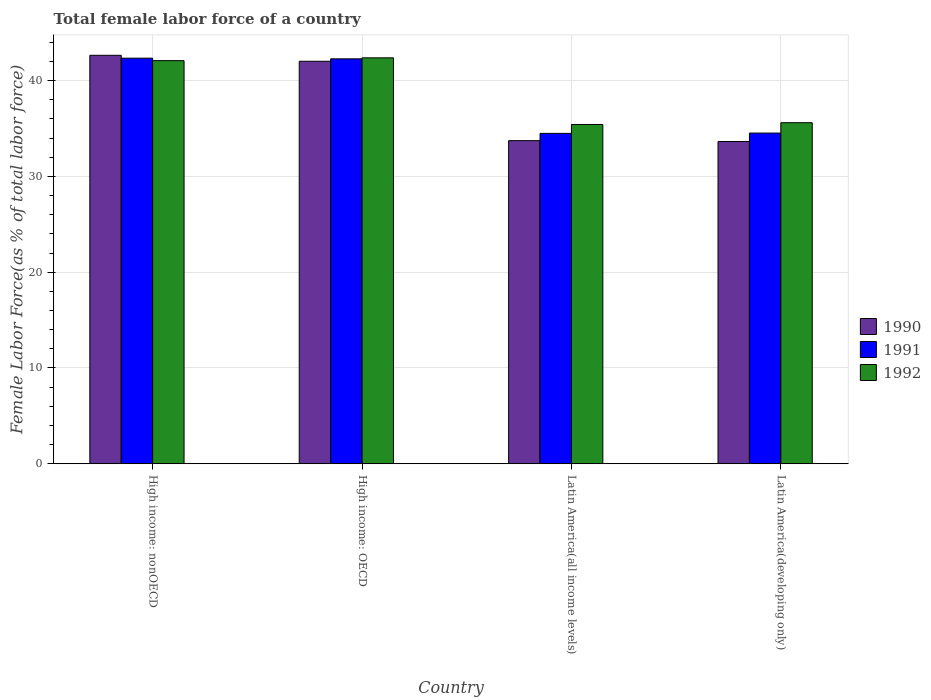Are the number of bars per tick equal to the number of legend labels?
Offer a very short reply. Yes. Are the number of bars on each tick of the X-axis equal?
Keep it short and to the point. Yes. How many bars are there on the 4th tick from the left?
Offer a terse response. 3. What is the label of the 1st group of bars from the left?
Provide a succinct answer. High income: nonOECD. What is the percentage of female labor force in 1992 in High income: nonOECD?
Offer a terse response. 42.08. Across all countries, what is the maximum percentage of female labor force in 1990?
Offer a very short reply. 42.64. Across all countries, what is the minimum percentage of female labor force in 1990?
Your answer should be compact. 33.64. In which country was the percentage of female labor force in 1992 maximum?
Offer a very short reply. High income: OECD. In which country was the percentage of female labor force in 1992 minimum?
Offer a terse response. Latin America(all income levels). What is the total percentage of female labor force in 1990 in the graph?
Your answer should be very brief. 152.04. What is the difference between the percentage of female labor force in 1990 in High income: OECD and that in High income: nonOECD?
Provide a succinct answer. -0.62. What is the difference between the percentage of female labor force in 1990 in Latin America(all income levels) and the percentage of female labor force in 1992 in Latin America(developing only)?
Provide a short and direct response. -1.87. What is the average percentage of female labor force in 1991 per country?
Provide a short and direct response. 38.41. What is the difference between the percentage of female labor force of/in 1990 and percentage of female labor force of/in 1991 in High income: nonOECD?
Ensure brevity in your answer.  0.3. What is the ratio of the percentage of female labor force in 1992 in High income: OECD to that in Latin America(all income levels)?
Ensure brevity in your answer.  1.2. Is the percentage of female labor force in 1991 in High income: OECD less than that in Latin America(developing only)?
Your answer should be compact. No. What is the difference between the highest and the second highest percentage of female labor force in 1992?
Your response must be concise. 6.77. What is the difference between the highest and the lowest percentage of female labor force in 1991?
Your response must be concise. 7.85. Is the sum of the percentage of female labor force in 1992 in High income: OECD and High income: nonOECD greater than the maximum percentage of female labor force in 1990 across all countries?
Ensure brevity in your answer.  Yes. What does the 2nd bar from the left in Latin America(all income levels) represents?
Your answer should be compact. 1991. Is it the case that in every country, the sum of the percentage of female labor force in 1992 and percentage of female labor force in 1991 is greater than the percentage of female labor force in 1990?
Give a very brief answer. Yes. How many bars are there?
Provide a succinct answer. 12. Are all the bars in the graph horizontal?
Provide a short and direct response. No. What is the difference between two consecutive major ticks on the Y-axis?
Your answer should be compact. 10. What is the title of the graph?
Provide a succinct answer. Total female labor force of a country. What is the label or title of the Y-axis?
Give a very brief answer. Female Labor Force(as % of total labor force). What is the Female Labor Force(as % of total labor force) in 1990 in High income: nonOECD?
Keep it short and to the point. 42.64. What is the Female Labor Force(as % of total labor force) in 1991 in High income: nonOECD?
Your answer should be very brief. 42.34. What is the Female Labor Force(as % of total labor force) in 1992 in High income: nonOECD?
Make the answer very short. 42.08. What is the Female Labor Force(as % of total labor force) in 1990 in High income: OECD?
Offer a terse response. 42.02. What is the Female Labor Force(as % of total labor force) of 1991 in High income: OECD?
Make the answer very short. 42.27. What is the Female Labor Force(as % of total labor force) of 1992 in High income: OECD?
Give a very brief answer. 42.38. What is the Female Labor Force(as % of total labor force) of 1990 in Latin America(all income levels)?
Your answer should be compact. 33.73. What is the Female Labor Force(as % of total labor force) of 1991 in Latin America(all income levels)?
Keep it short and to the point. 34.49. What is the Female Labor Force(as % of total labor force) in 1992 in Latin America(all income levels)?
Give a very brief answer. 35.42. What is the Female Labor Force(as % of total labor force) of 1990 in Latin America(developing only)?
Provide a short and direct response. 33.64. What is the Female Labor Force(as % of total labor force) of 1991 in Latin America(developing only)?
Keep it short and to the point. 34.52. What is the Female Labor Force(as % of total labor force) of 1992 in Latin America(developing only)?
Provide a succinct answer. 35.6. Across all countries, what is the maximum Female Labor Force(as % of total labor force) of 1990?
Offer a terse response. 42.64. Across all countries, what is the maximum Female Labor Force(as % of total labor force) of 1991?
Your answer should be compact. 42.34. Across all countries, what is the maximum Female Labor Force(as % of total labor force) in 1992?
Ensure brevity in your answer.  42.38. Across all countries, what is the minimum Female Labor Force(as % of total labor force) of 1990?
Make the answer very short. 33.64. Across all countries, what is the minimum Female Labor Force(as % of total labor force) in 1991?
Give a very brief answer. 34.49. Across all countries, what is the minimum Female Labor Force(as % of total labor force) of 1992?
Make the answer very short. 35.42. What is the total Female Labor Force(as % of total labor force) of 1990 in the graph?
Make the answer very short. 152.04. What is the total Female Labor Force(as % of total labor force) in 1991 in the graph?
Your answer should be very brief. 153.63. What is the total Female Labor Force(as % of total labor force) of 1992 in the graph?
Offer a very short reply. 155.49. What is the difference between the Female Labor Force(as % of total labor force) in 1990 in High income: nonOECD and that in High income: OECD?
Offer a terse response. 0.62. What is the difference between the Female Labor Force(as % of total labor force) in 1991 in High income: nonOECD and that in High income: OECD?
Keep it short and to the point. 0.07. What is the difference between the Female Labor Force(as % of total labor force) of 1992 in High income: nonOECD and that in High income: OECD?
Your answer should be compact. -0.29. What is the difference between the Female Labor Force(as % of total labor force) of 1990 in High income: nonOECD and that in Latin America(all income levels)?
Offer a very short reply. 8.91. What is the difference between the Female Labor Force(as % of total labor force) of 1991 in High income: nonOECD and that in Latin America(all income levels)?
Your answer should be compact. 7.85. What is the difference between the Female Labor Force(as % of total labor force) of 1992 in High income: nonOECD and that in Latin America(all income levels)?
Offer a very short reply. 6.66. What is the difference between the Female Labor Force(as % of total labor force) of 1990 in High income: nonOECD and that in Latin America(developing only)?
Ensure brevity in your answer.  9. What is the difference between the Female Labor Force(as % of total labor force) of 1991 in High income: nonOECD and that in Latin America(developing only)?
Provide a short and direct response. 7.82. What is the difference between the Female Labor Force(as % of total labor force) of 1992 in High income: nonOECD and that in Latin America(developing only)?
Your answer should be very brief. 6.48. What is the difference between the Female Labor Force(as % of total labor force) in 1990 in High income: OECD and that in Latin America(all income levels)?
Offer a terse response. 8.29. What is the difference between the Female Labor Force(as % of total labor force) in 1991 in High income: OECD and that in Latin America(all income levels)?
Your response must be concise. 7.78. What is the difference between the Female Labor Force(as % of total labor force) in 1992 in High income: OECD and that in Latin America(all income levels)?
Your answer should be very brief. 6.96. What is the difference between the Female Labor Force(as % of total labor force) in 1990 in High income: OECD and that in Latin America(developing only)?
Ensure brevity in your answer.  8.38. What is the difference between the Female Labor Force(as % of total labor force) of 1991 in High income: OECD and that in Latin America(developing only)?
Keep it short and to the point. 7.75. What is the difference between the Female Labor Force(as % of total labor force) of 1992 in High income: OECD and that in Latin America(developing only)?
Provide a short and direct response. 6.77. What is the difference between the Female Labor Force(as % of total labor force) in 1990 in Latin America(all income levels) and that in Latin America(developing only)?
Your answer should be compact. 0.09. What is the difference between the Female Labor Force(as % of total labor force) in 1991 in Latin America(all income levels) and that in Latin America(developing only)?
Offer a terse response. -0.03. What is the difference between the Female Labor Force(as % of total labor force) in 1992 in Latin America(all income levels) and that in Latin America(developing only)?
Offer a very short reply. -0.18. What is the difference between the Female Labor Force(as % of total labor force) in 1990 in High income: nonOECD and the Female Labor Force(as % of total labor force) in 1991 in High income: OECD?
Ensure brevity in your answer.  0.37. What is the difference between the Female Labor Force(as % of total labor force) of 1990 in High income: nonOECD and the Female Labor Force(as % of total labor force) of 1992 in High income: OECD?
Your answer should be compact. 0.27. What is the difference between the Female Labor Force(as % of total labor force) in 1991 in High income: nonOECD and the Female Labor Force(as % of total labor force) in 1992 in High income: OECD?
Offer a very short reply. -0.04. What is the difference between the Female Labor Force(as % of total labor force) in 1990 in High income: nonOECD and the Female Labor Force(as % of total labor force) in 1991 in Latin America(all income levels)?
Provide a short and direct response. 8.15. What is the difference between the Female Labor Force(as % of total labor force) of 1990 in High income: nonOECD and the Female Labor Force(as % of total labor force) of 1992 in Latin America(all income levels)?
Ensure brevity in your answer.  7.22. What is the difference between the Female Labor Force(as % of total labor force) in 1991 in High income: nonOECD and the Female Labor Force(as % of total labor force) in 1992 in Latin America(all income levels)?
Offer a terse response. 6.92. What is the difference between the Female Labor Force(as % of total labor force) in 1990 in High income: nonOECD and the Female Labor Force(as % of total labor force) in 1991 in Latin America(developing only)?
Your answer should be very brief. 8.12. What is the difference between the Female Labor Force(as % of total labor force) in 1990 in High income: nonOECD and the Female Labor Force(as % of total labor force) in 1992 in Latin America(developing only)?
Provide a succinct answer. 7.04. What is the difference between the Female Labor Force(as % of total labor force) of 1991 in High income: nonOECD and the Female Labor Force(as % of total labor force) of 1992 in Latin America(developing only)?
Ensure brevity in your answer.  6.74. What is the difference between the Female Labor Force(as % of total labor force) of 1990 in High income: OECD and the Female Labor Force(as % of total labor force) of 1991 in Latin America(all income levels)?
Give a very brief answer. 7.53. What is the difference between the Female Labor Force(as % of total labor force) in 1990 in High income: OECD and the Female Labor Force(as % of total labor force) in 1992 in Latin America(all income levels)?
Your response must be concise. 6.6. What is the difference between the Female Labor Force(as % of total labor force) in 1991 in High income: OECD and the Female Labor Force(as % of total labor force) in 1992 in Latin America(all income levels)?
Provide a short and direct response. 6.85. What is the difference between the Female Labor Force(as % of total labor force) in 1990 in High income: OECD and the Female Labor Force(as % of total labor force) in 1991 in Latin America(developing only)?
Your answer should be very brief. 7.5. What is the difference between the Female Labor Force(as % of total labor force) of 1990 in High income: OECD and the Female Labor Force(as % of total labor force) of 1992 in Latin America(developing only)?
Make the answer very short. 6.42. What is the difference between the Female Labor Force(as % of total labor force) in 1991 in High income: OECD and the Female Labor Force(as % of total labor force) in 1992 in Latin America(developing only)?
Ensure brevity in your answer.  6.67. What is the difference between the Female Labor Force(as % of total labor force) of 1990 in Latin America(all income levels) and the Female Labor Force(as % of total labor force) of 1991 in Latin America(developing only)?
Your answer should be compact. -0.79. What is the difference between the Female Labor Force(as % of total labor force) of 1990 in Latin America(all income levels) and the Female Labor Force(as % of total labor force) of 1992 in Latin America(developing only)?
Keep it short and to the point. -1.87. What is the difference between the Female Labor Force(as % of total labor force) in 1991 in Latin America(all income levels) and the Female Labor Force(as % of total labor force) in 1992 in Latin America(developing only)?
Provide a short and direct response. -1.11. What is the average Female Labor Force(as % of total labor force) of 1990 per country?
Offer a very short reply. 38.01. What is the average Female Labor Force(as % of total labor force) of 1991 per country?
Your response must be concise. 38.41. What is the average Female Labor Force(as % of total labor force) in 1992 per country?
Offer a terse response. 38.87. What is the difference between the Female Labor Force(as % of total labor force) in 1990 and Female Labor Force(as % of total labor force) in 1991 in High income: nonOECD?
Ensure brevity in your answer.  0.3. What is the difference between the Female Labor Force(as % of total labor force) of 1990 and Female Labor Force(as % of total labor force) of 1992 in High income: nonOECD?
Offer a very short reply. 0.56. What is the difference between the Female Labor Force(as % of total labor force) in 1991 and Female Labor Force(as % of total labor force) in 1992 in High income: nonOECD?
Provide a short and direct response. 0.26. What is the difference between the Female Labor Force(as % of total labor force) of 1990 and Female Labor Force(as % of total labor force) of 1991 in High income: OECD?
Provide a short and direct response. -0.25. What is the difference between the Female Labor Force(as % of total labor force) in 1990 and Female Labor Force(as % of total labor force) in 1992 in High income: OECD?
Your answer should be very brief. -0.36. What is the difference between the Female Labor Force(as % of total labor force) in 1991 and Female Labor Force(as % of total labor force) in 1992 in High income: OECD?
Offer a very short reply. -0.11. What is the difference between the Female Labor Force(as % of total labor force) in 1990 and Female Labor Force(as % of total labor force) in 1991 in Latin America(all income levels)?
Your response must be concise. -0.76. What is the difference between the Female Labor Force(as % of total labor force) of 1990 and Female Labor Force(as % of total labor force) of 1992 in Latin America(all income levels)?
Your answer should be very brief. -1.69. What is the difference between the Female Labor Force(as % of total labor force) in 1991 and Female Labor Force(as % of total labor force) in 1992 in Latin America(all income levels)?
Offer a very short reply. -0.93. What is the difference between the Female Labor Force(as % of total labor force) of 1990 and Female Labor Force(as % of total labor force) of 1991 in Latin America(developing only)?
Provide a succinct answer. -0.88. What is the difference between the Female Labor Force(as % of total labor force) in 1990 and Female Labor Force(as % of total labor force) in 1992 in Latin America(developing only)?
Your answer should be very brief. -1.96. What is the difference between the Female Labor Force(as % of total labor force) of 1991 and Female Labor Force(as % of total labor force) of 1992 in Latin America(developing only)?
Keep it short and to the point. -1.08. What is the ratio of the Female Labor Force(as % of total labor force) of 1990 in High income: nonOECD to that in High income: OECD?
Your answer should be very brief. 1.01. What is the ratio of the Female Labor Force(as % of total labor force) in 1991 in High income: nonOECD to that in High income: OECD?
Make the answer very short. 1. What is the ratio of the Female Labor Force(as % of total labor force) of 1990 in High income: nonOECD to that in Latin America(all income levels)?
Offer a very short reply. 1.26. What is the ratio of the Female Labor Force(as % of total labor force) of 1991 in High income: nonOECD to that in Latin America(all income levels)?
Provide a succinct answer. 1.23. What is the ratio of the Female Labor Force(as % of total labor force) of 1992 in High income: nonOECD to that in Latin America(all income levels)?
Ensure brevity in your answer.  1.19. What is the ratio of the Female Labor Force(as % of total labor force) of 1990 in High income: nonOECD to that in Latin America(developing only)?
Offer a very short reply. 1.27. What is the ratio of the Female Labor Force(as % of total labor force) in 1991 in High income: nonOECD to that in Latin America(developing only)?
Ensure brevity in your answer.  1.23. What is the ratio of the Female Labor Force(as % of total labor force) of 1992 in High income: nonOECD to that in Latin America(developing only)?
Your answer should be very brief. 1.18. What is the ratio of the Female Labor Force(as % of total labor force) in 1990 in High income: OECD to that in Latin America(all income levels)?
Your response must be concise. 1.25. What is the ratio of the Female Labor Force(as % of total labor force) in 1991 in High income: OECD to that in Latin America(all income levels)?
Provide a succinct answer. 1.23. What is the ratio of the Female Labor Force(as % of total labor force) in 1992 in High income: OECD to that in Latin America(all income levels)?
Make the answer very short. 1.2. What is the ratio of the Female Labor Force(as % of total labor force) in 1990 in High income: OECD to that in Latin America(developing only)?
Your response must be concise. 1.25. What is the ratio of the Female Labor Force(as % of total labor force) of 1991 in High income: OECD to that in Latin America(developing only)?
Give a very brief answer. 1.22. What is the ratio of the Female Labor Force(as % of total labor force) of 1992 in High income: OECD to that in Latin America(developing only)?
Keep it short and to the point. 1.19. What is the ratio of the Female Labor Force(as % of total labor force) of 1990 in Latin America(all income levels) to that in Latin America(developing only)?
Make the answer very short. 1. What is the difference between the highest and the second highest Female Labor Force(as % of total labor force) of 1990?
Your answer should be very brief. 0.62. What is the difference between the highest and the second highest Female Labor Force(as % of total labor force) of 1991?
Give a very brief answer. 0.07. What is the difference between the highest and the second highest Female Labor Force(as % of total labor force) in 1992?
Your answer should be very brief. 0.29. What is the difference between the highest and the lowest Female Labor Force(as % of total labor force) in 1990?
Keep it short and to the point. 9. What is the difference between the highest and the lowest Female Labor Force(as % of total labor force) in 1991?
Ensure brevity in your answer.  7.85. What is the difference between the highest and the lowest Female Labor Force(as % of total labor force) of 1992?
Your response must be concise. 6.96. 